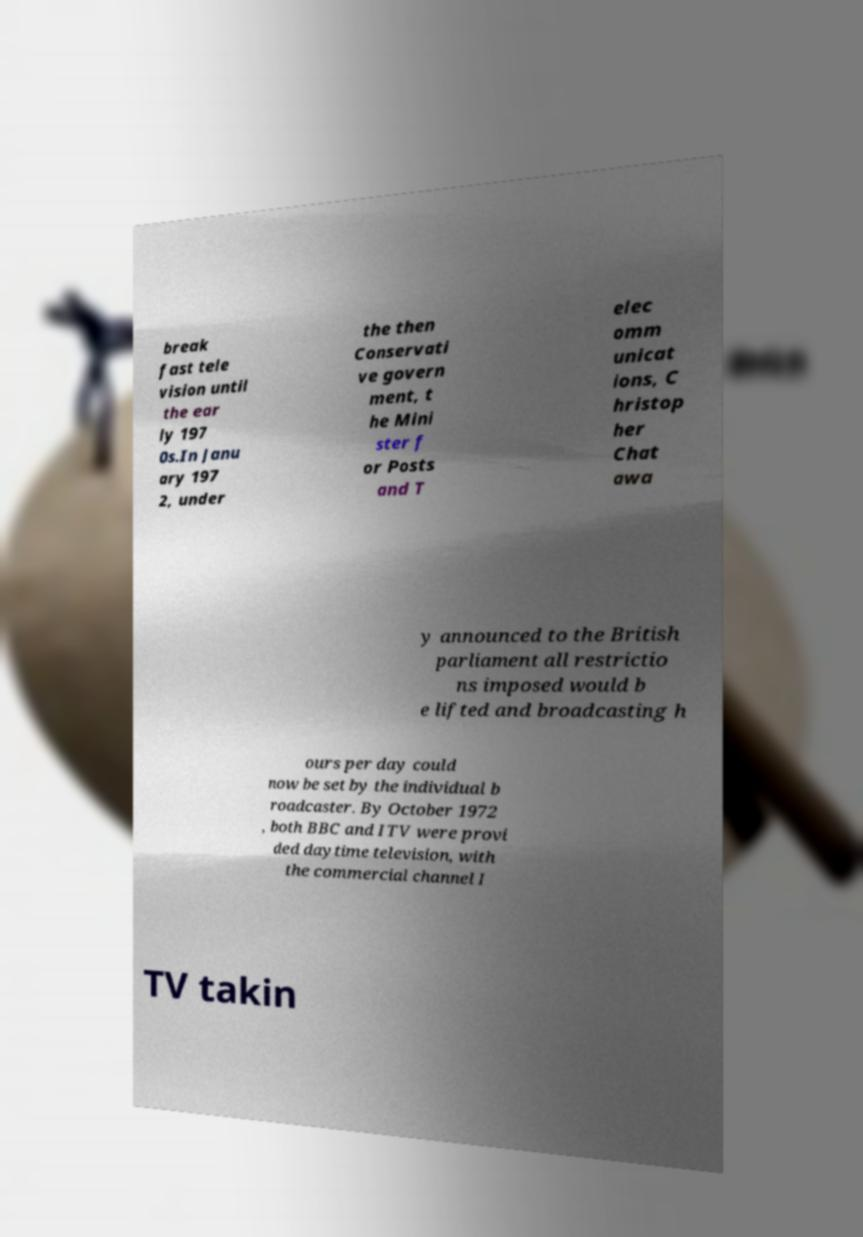Please identify and transcribe the text found in this image. break fast tele vision until the ear ly 197 0s.In Janu ary 197 2, under the then Conservati ve govern ment, t he Mini ster f or Posts and T elec omm unicat ions, C hristop her Chat awa y announced to the British parliament all restrictio ns imposed would b e lifted and broadcasting h ours per day could now be set by the individual b roadcaster. By October 1972 , both BBC and ITV were provi ded daytime television, with the commercial channel I TV takin 